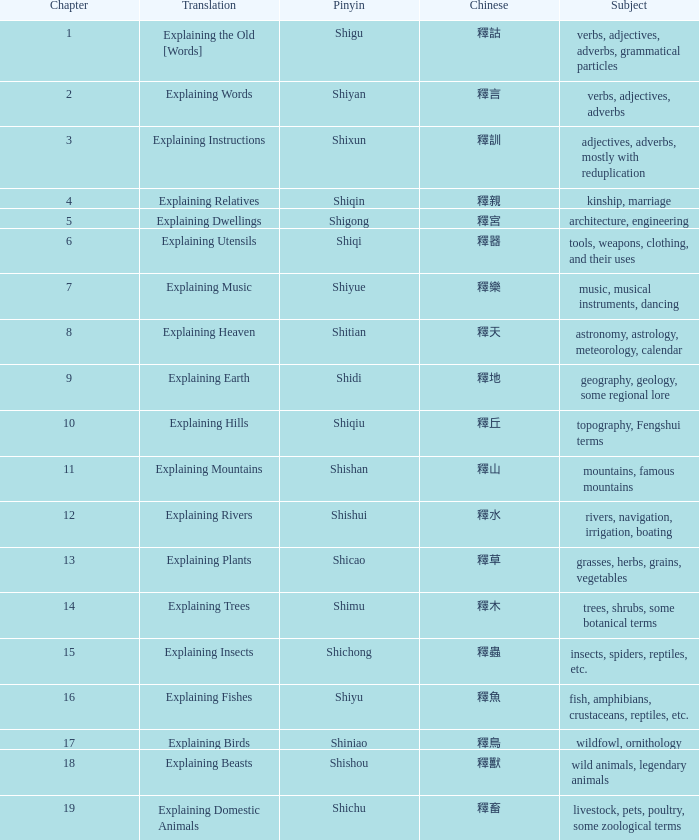Name the subject of shiyan Verbs, adjectives, adverbs. 